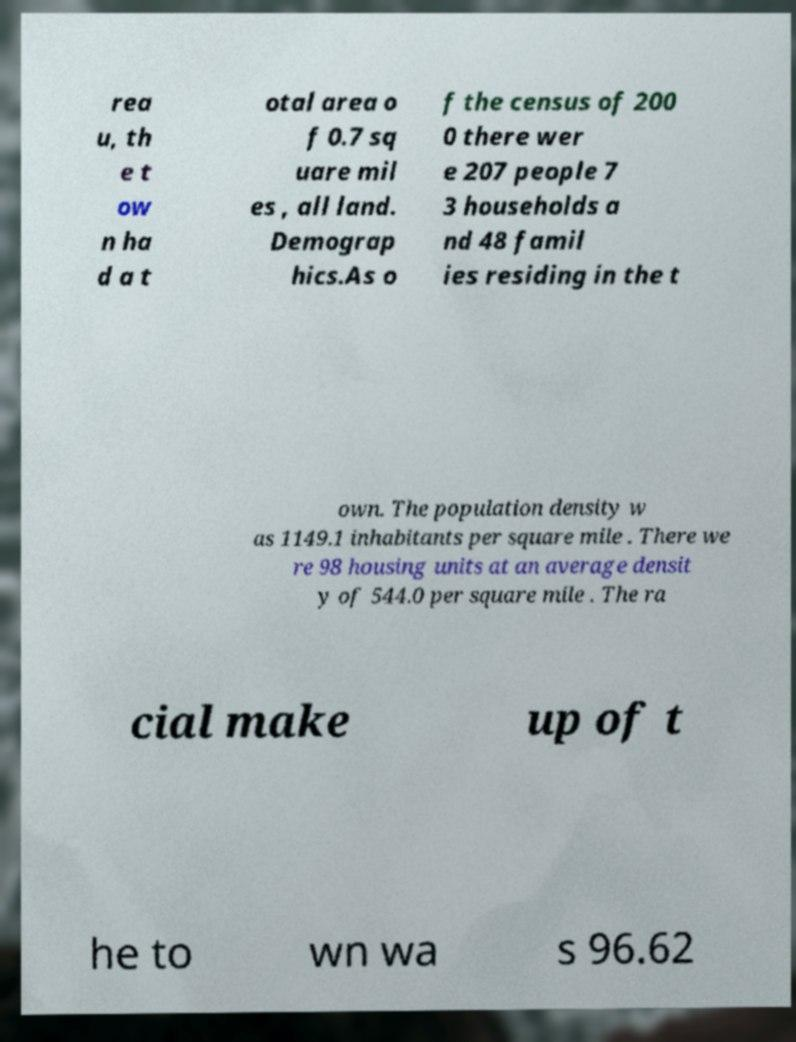Please read and relay the text visible in this image. What does it say? rea u, th e t ow n ha d a t otal area o f 0.7 sq uare mil es , all land. Demograp hics.As o f the census of 200 0 there wer e 207 people 7 3 households a nd 48 famil ies residing in the t own. The population density w as 1149.1 inhabitants per square mile . There we re 98 housing units at an average densit y of 544.0 per square mile . The ra cial make up of t he to wn wa s 96.62 